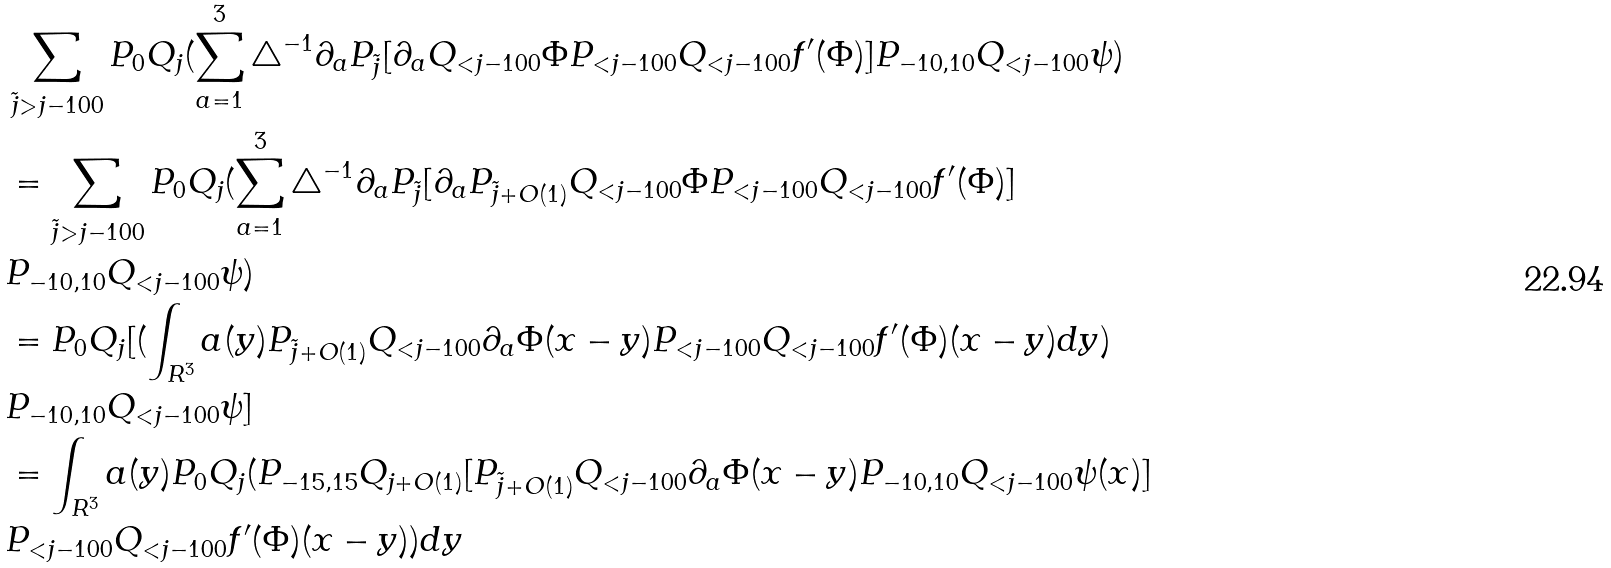Convert formula to latex. <formula><loc_0><loc_0><loc_500><loc_500>& \sum _ { \tilde { j } > j - 1 0 0 } P _ { 0 } Q _ { j } ( \sum _ { a = 1 } ^ { 3 } \triangle ^ { - 1 } \partial _ { a } P _ { \tilde { j } } [ \partial _ { a } Q _ { < j - 1 0 0 } \Phi P _ { < j - 1 0 0 } Q _ { < j - 1 0 0 } f ^ { \prime } ( \Phi ) ] P _ { - 1 0 , 1 0 } Q _ { < j - 1 0 0 } \psi ) \\ & = \sum _ { \tilde { j } > j - 1 0 0 } P _ { 0 } Q _ { j } ( \sum _ { a = 1 } ^ { 3 } \triangle ^ { - 1 } \partial _ { a } P _ { \tilde { j } } [ \partial _ { a } P _ { \tilde { j } + O ( 1 ) } Q _ { < j - 1 0 0 } \Phi P _ { < j - 1 0 0 } Q _ { < j - 1 0 0 } f ^ { \prime } ( \Phi ) ] \\ & P _ { - 1 0 , 1 0 } Q _ { < j - 1 0 0 } \psi ) \\ & = P _ { 0 } Q _ { j } [ ( \int _ { R ^ { 3 } } a ( y ) P _ { \tilde { j } + O ( 1 ) } Q _ { < j - 1 0 0 } \partial _ { a } \Phi ( x - y ) P _ { < j - 1 0 0 } Q _ { < j - 1 0 0 } f ^ { \prime } ( \Phi ) ( x - y ) d y ) \\ & P _ { - 1 0 , 1 0 } Q _ { < j - 1 0 0 } \psi ] \\ & = \int _ { R ^ { 3 } } a ( y ) P _ { 0 } Q _ { j } ( P _ { - 1 5 , 1 5 } Q _ { j + O ( 1 ) } [ P _ { \tilde { j } + O ( 1 ) } Q _ { < j - 1 0 0 } \partial _ { a } \Phi ( x - y ) P _ { - 1 0 , 1 0 } Q _ { < j - 1 0 0 } \psi ( x ) ] \\ & P _ { < j - 1 0 0 } Q _ { < j - 1 0 0 } f ^ { \prime } ( \Phi ) ( x - y ) ) d y \\</formula> 